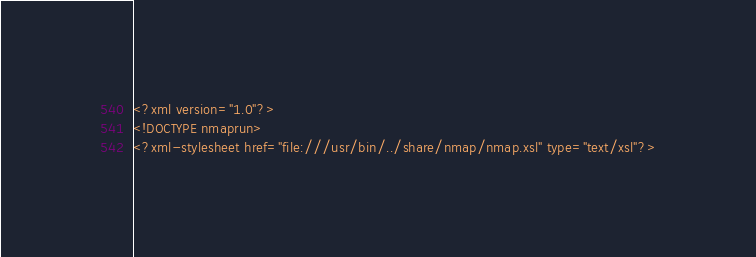<code> <loc_0><loc_0><loc_500><loc_500><_XML_><?xml version="1.0"?>
<!DOCTYPE nmaprun>
<?xml-stylesheet href="file:///usr/bin/../share/nmap/nmap.xsl" type="text/xsl"?></code> 